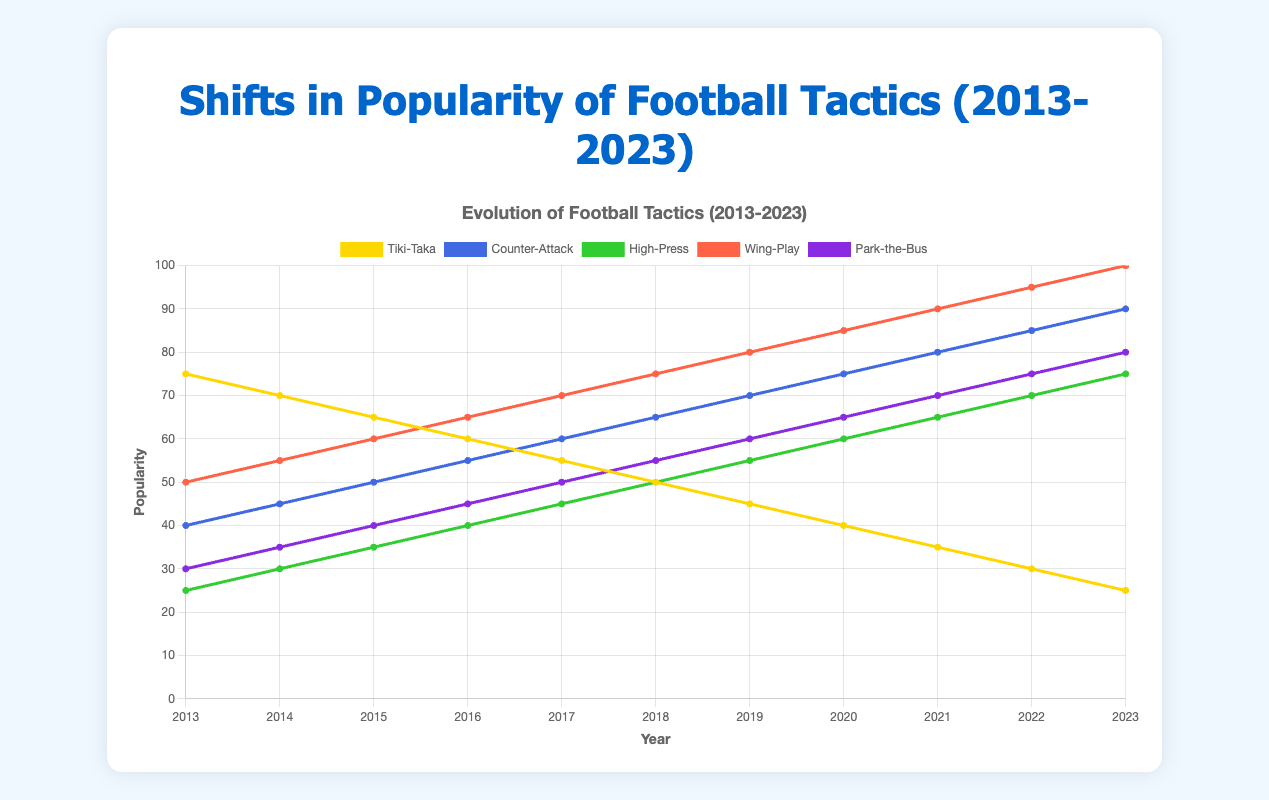What tactic had the highest popularity in 2023? We look for the highest point on the y-axis for the year 2023. The 'Wing-Play' tactic reaches 100, which is the highest value among the tactics for 2023.
Answer: Wing-Play How did the popularity of 'Tiki-Taka' change from 2013 to 2023? Comparing the values from 2013 and 2023, 'Tiki-Taka' starts at 75 in 2013 and decreases to 25 in 2023.
Answer: Decreased by 50 Which tactic had the largest increase in popularity between 2013 and 2023? We calculate the difference in popularity for each tactic between 2013 and 2023, comparing the values: Tiki-Taka (-50), Counter-Attack (+50), High-Press (+50), Wing-Play (+50), Park-the-Bus (+50). Since they all have the same increase of 50, we can select any of them.
Answer: Counter-Attack (or High-Press, Wing-Play, Park-the-Bus) In 2018, which two tactics had the closest popularity values? In 2018, the values are 'Tiki-Taka' 50, 'Counter-Attack' 65, 'High-Press' 50, 'Wing-Play' 75, 'Park-the-Bus' 55. The closest values are 'Tiki-Taka' (50) and 'High-Press' (50) which are exactly the same.
Answer: Tiki-Taka and High-Press Which tactic shows a consistent increase in popularity over the decade? Observing the trends over the decade from 2013 to 2023, 'Counter-Attack', 'High-Press', 'Wing-Play', and 'Park-the-Bus' show consistent increases.
Answer: Counter-Attack, High-Press, Wing-Play, Park-the-Bus What was the popularity change for 'High-Press' from 2015 to 2018? The popularity of 'High-Press' was 35 in 2015 and 50 in 2018. The difference is 50 - 35 = 15.
Answer: Increased by 15 Compare the popularity of 'Park-the-Bus' and 'High-Press' in 2020. Which one was higher? In 2020, 'Park-the-Bus' has a popularity of 65, while 'High-Press' has a popularity of 60. 'Park-the-Bus' is higher by 5 units.
Answer: Park-the-Bus What is the average popularity of 'Wing-Play' from 2013 to 2018? The values for 'Wing-Play' from 2013 to 2018 are 50, 55, 60, 65, 70, 75. Adding them gives us 50 + 55 + 60 + 65 + 70 + 75 = 375. Dividing by 6 gives us 375 / 6 = 62.5.
Answer: 62.5 